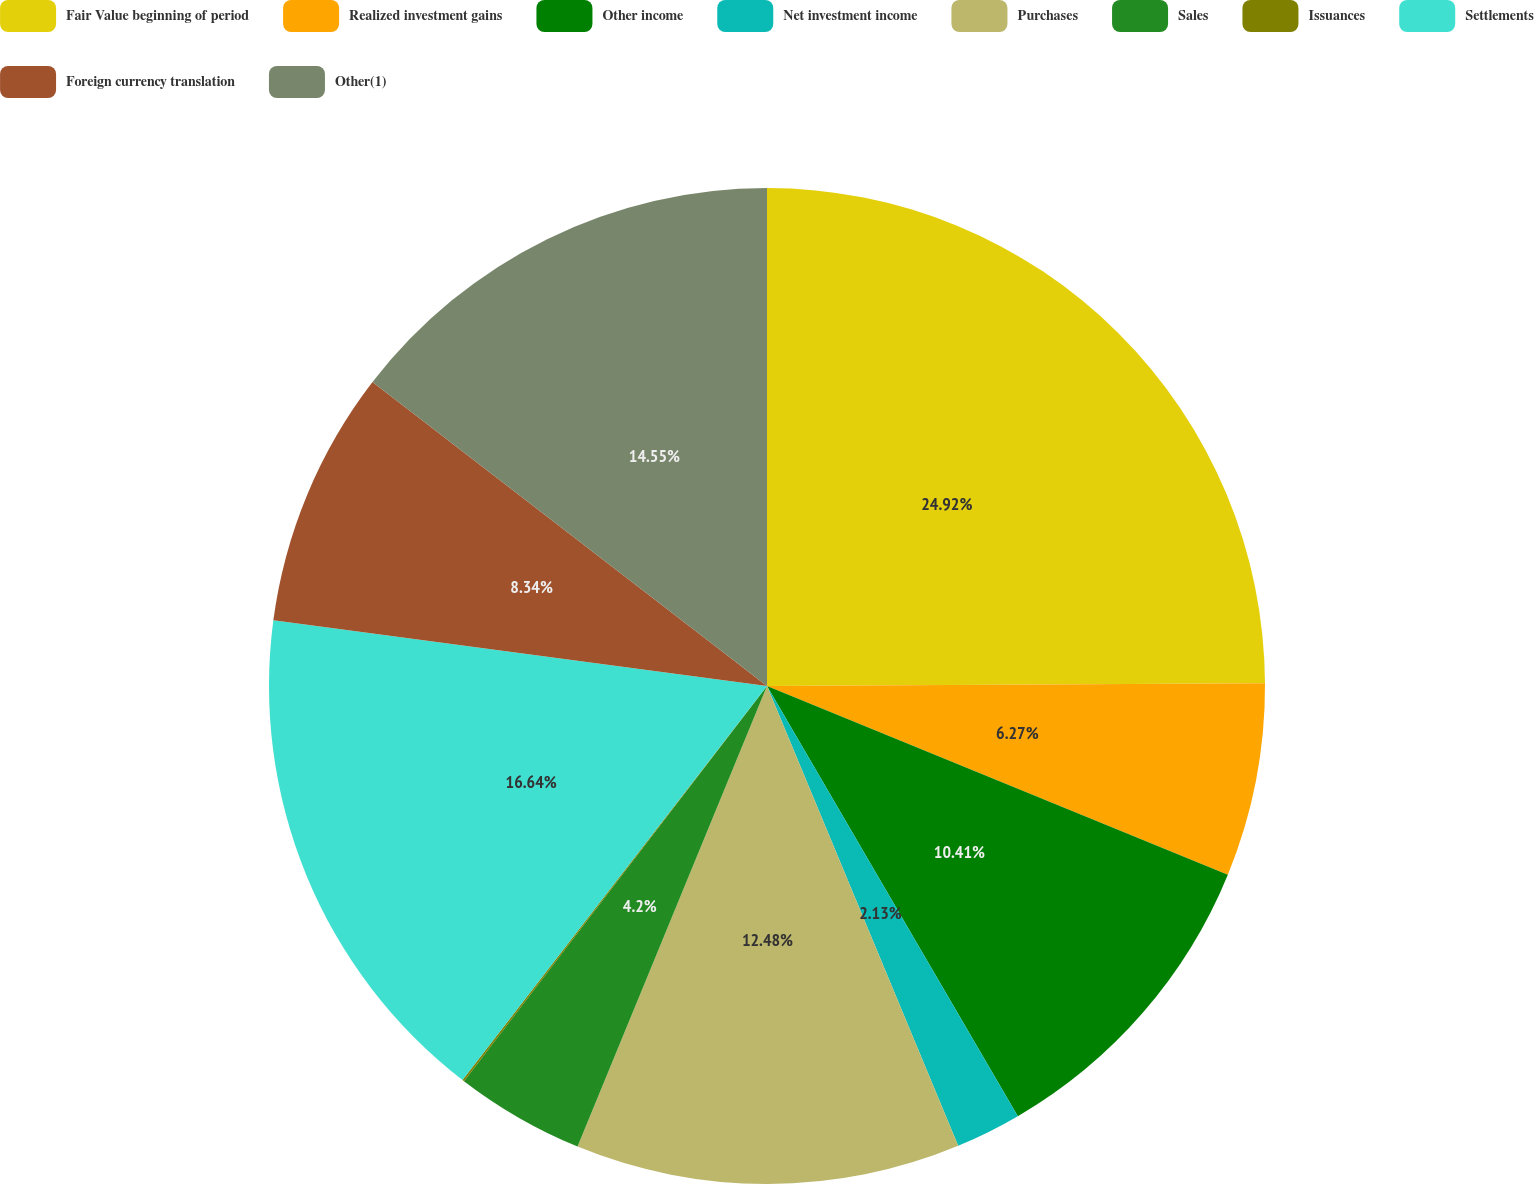<chart> <loc_0><loc_0><loc_500><loc_500><pie_chart><fcel>Fair Value beginning of period<fcel>Realized investment gains<fcel>Other income<fcel>Net investment income<fcel>Purchases<fcel>Sales<fcel>Issuances<fcel>Settlements<fcel>Foreign currency translation<fcel>Other(1)<nl><fcel>24.91%<fcel>6.27%<fcel>10.41%<fcel>2.13%<fcel>12.48%<fcel>4.2%<fcel>0.06%<fcel>16.63%<fcel>8.34%<fcel>14.55%<nl></chart> 